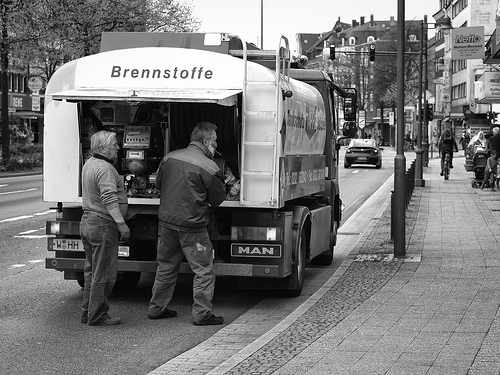How many stoplights are on the pole? Based on the black and white image presented, there is no clear presence of a stoplight on the visible poles. The focus of the image is on two individuals by a fuel truck, and the surroundings include a city street scene. If the question refers to traffic lights, it appears there are no such lights visible in this scene. 